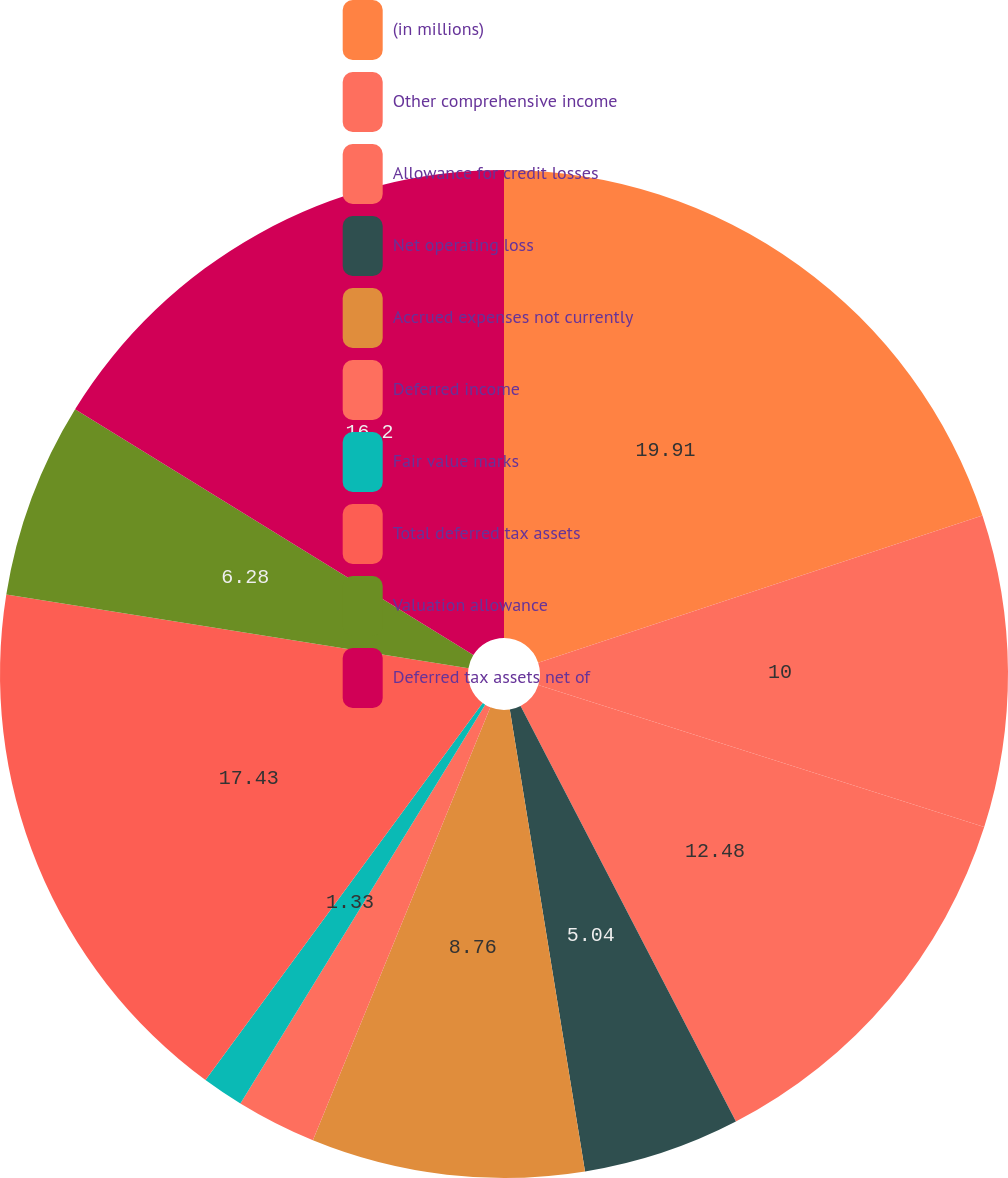<chart> <loc_0><loc_0><loc_500><loc_500><pie_chart><fcel>(in millions)<fcel>Other comprehensive income<fcel>Allowance for credit losses<fcel>Net operating loss<fcel>Accrued expenses not currently<fcel>Deferred income<fcel>Fair value marks<fcel>Total deferred tax assets<fcel>Valuation allowance<fcel>Deferred tax assets net of<nl><fcel>19.91%<fcel>10.0%<fcel>12.48%<fcel>5.04%<fcel>8.76%<fcel>2.57%<fcel>1.33%<fcel>17.43%<fcel>6.28%<fcel>16.2%<nl></chart> 